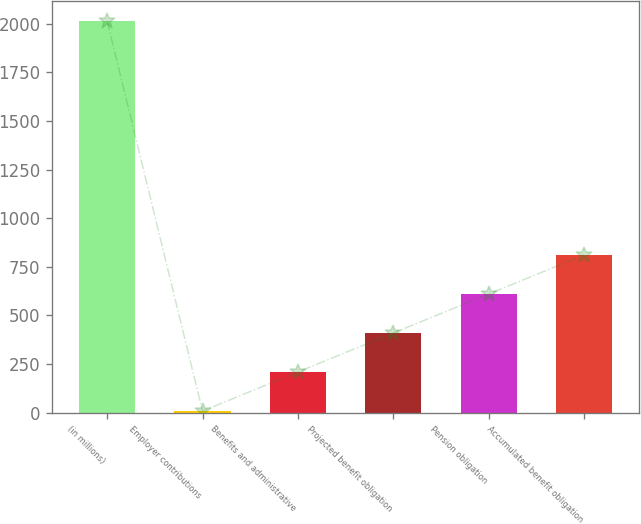<chart> <loc_0><loc_0><loc_500><loc_500><bar_chart><fcel>(in millions)<fcel>Employer contributions<fcel>Benefits and administrative<fcel>Projected benefit obligation<fcel>Pension obligation<fcel>Accumulated benefit obligation<nl><fcel>2015<fcel>9<fcel>209.6<fcel>410.2<fcel>610.8<fcel>811.4<nl></chart> 